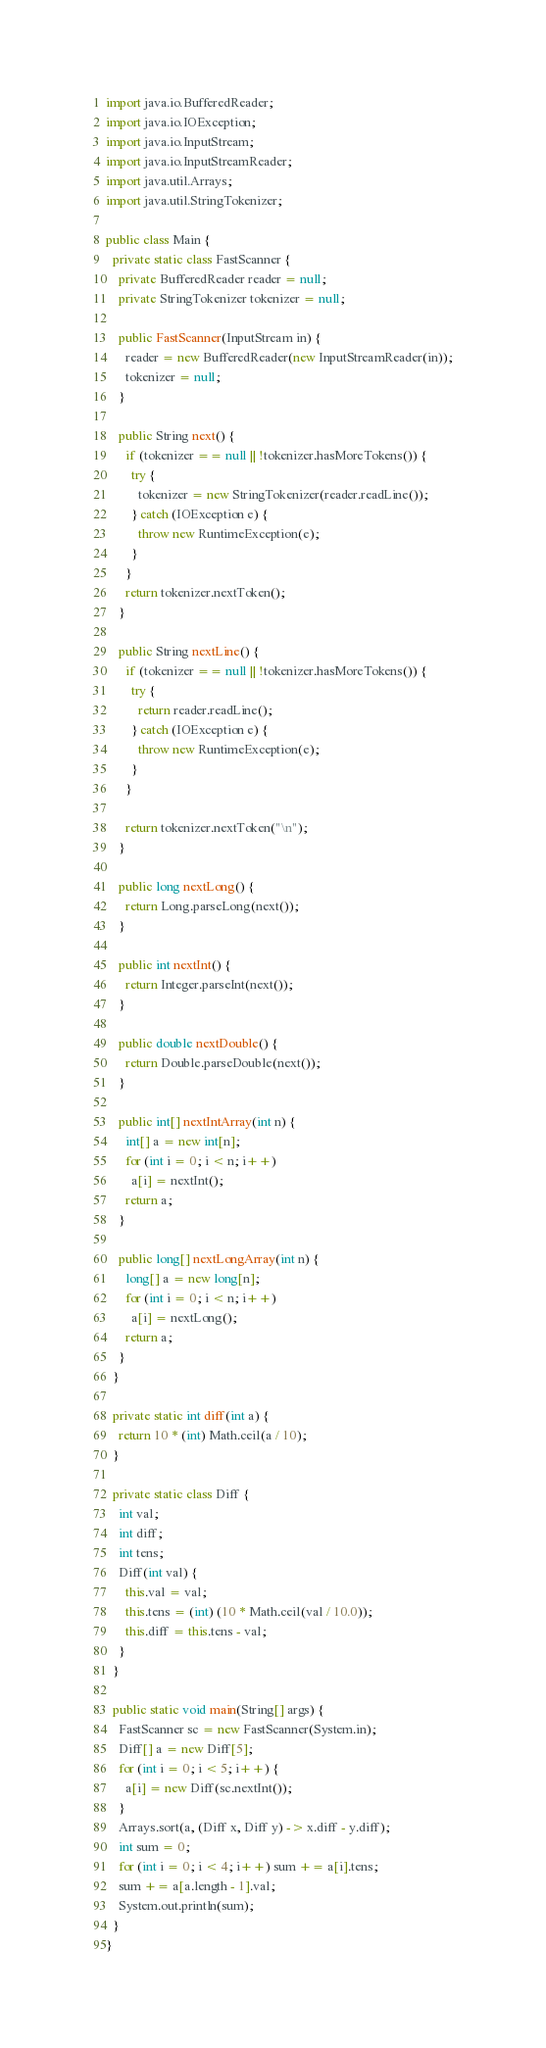<code> <loc_0><loc_0><loc_500><loc_500><_Java_>import java.io.BufferedReader;
import java.io.IOException;
import java.io.InputStream;
import java.io.InputStreamReader;
import java.util.Arrays;
import java.util.StringTokenizer;

public class Main {
  private static class FastScanner {
    private BufferedReader reader = null;
    private StringTokenizer tokenizer = null;

    public FastScanner(InputStream in) {
      reader = new BufferedReader(new InputStreamReader(in));
      tokenizer = null;
    }

    public String next() {
      if (tokenizer == null || !tokenizer.hasMoreTokens()) {
        try {
          tokenizer = new StringTokenizer(reader.readLine());
        } catch (IOException e) {
          throw new RuntimeException(e);
        }
      }
      return tokenizer.nextToken();
    }

    public String nextLine() {
      if (tokenizer == null || !tokenizer.hasMoreTokens()) {
        try {
          return reader.readLine();
        } catch (IOException e) {
          throw new RuntimeException(e);
        }
      }

      return tokenizer.nextToken("\n");
    }

    public long nextLong() {
      return Long.parseLong(next());
    }

    public int nextInt() {
      return Integer.parseInt(next());
    }

    public double nextDouble() {
      return Double.parseDouble(next());
    }

    public int[] nextIntArray(int n) {
      int[] a = new int[n];
      for (int i = 0; i < n; i++)
        a[i] = nextInt();
      return a;
    }

    public long[] nextLongArray(int n) {
      long[] a = new long[n];
      for (int i = 0; i < n; i++)
        a[i] = nextLong();
      return a;
    }
  }

  private static int diff(int a) {
    return 10 * (int) Math.ceil(a / 10);
  }

  private static class Diff {
    int val;
    int diff;
    int tens;
    Diff(int val) {
      this.val = val;
      this.tens = (int) (10 * Math.ceil(val / 10.0));
      this.diff = this.tens - val;
    }
  }

  public static void main(String[] args) {
    FastScanner sc = new FastScanner(System.in);
    Diff[] a = new Diff[5];
    for (int i = 0; i < 5; i++) {
      a[i] = new Diff(sc.nextInt());
    }
    Arrays.sort(a, (Diff x, Diff y) -> x.diff - y.diff);
    int sum = 0;
    for (int i = 0; i < 4; i++) sum += a[i].tens;
    sum += a[a.length - 1].val;
    System.out.println(sum);
  }
}</code> 